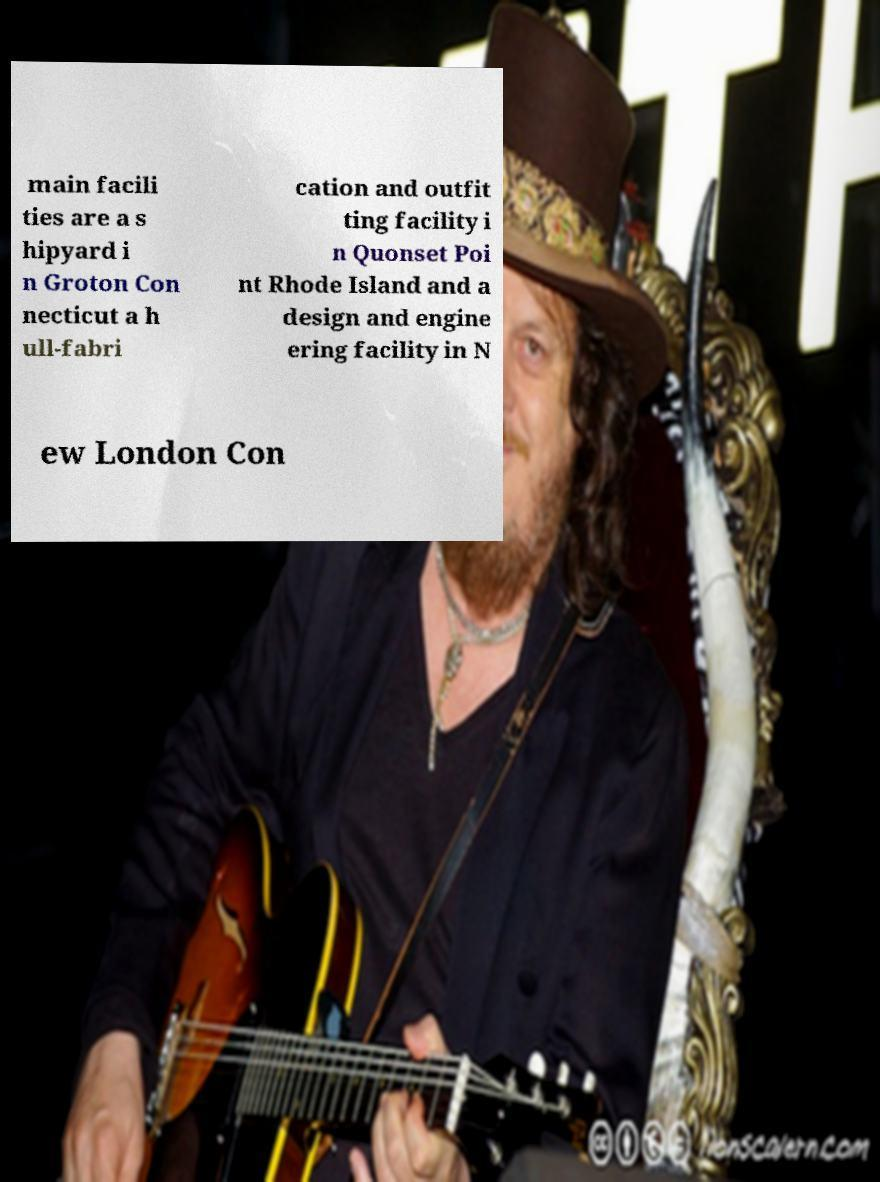For documentation purposes, I need the text within this image transcribed. Could you provide that? main facili ties are a s hipyard i n Groton Con necticut a h ull-fabri cation and outfit ting facility i n Quonset Poi nt Rhode Island and a design and engine ering facility in N ew London Con 